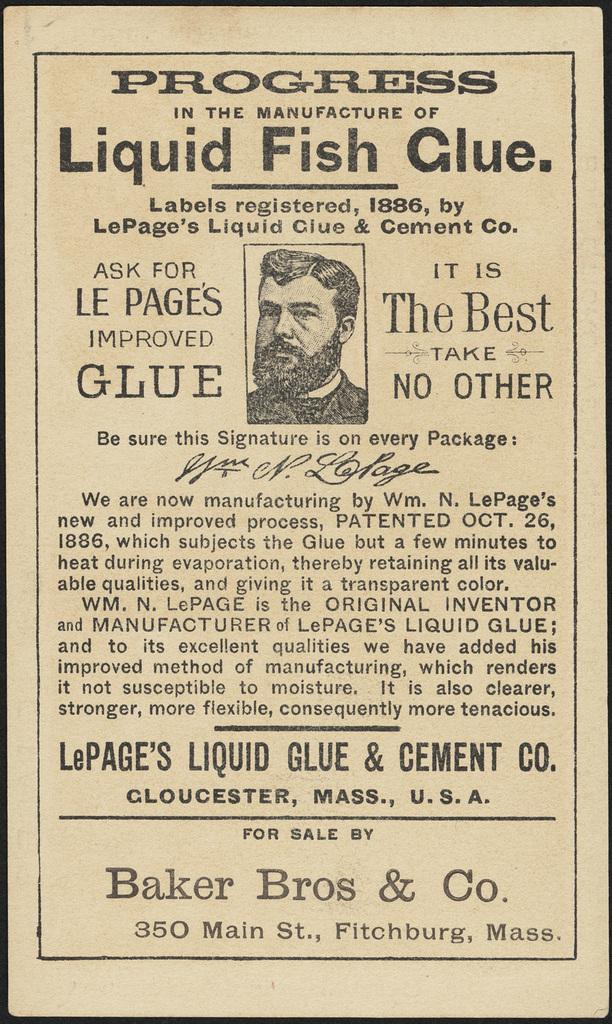Describe this image in one or two sentences. In this image there is a poster with persons image and note around it. 